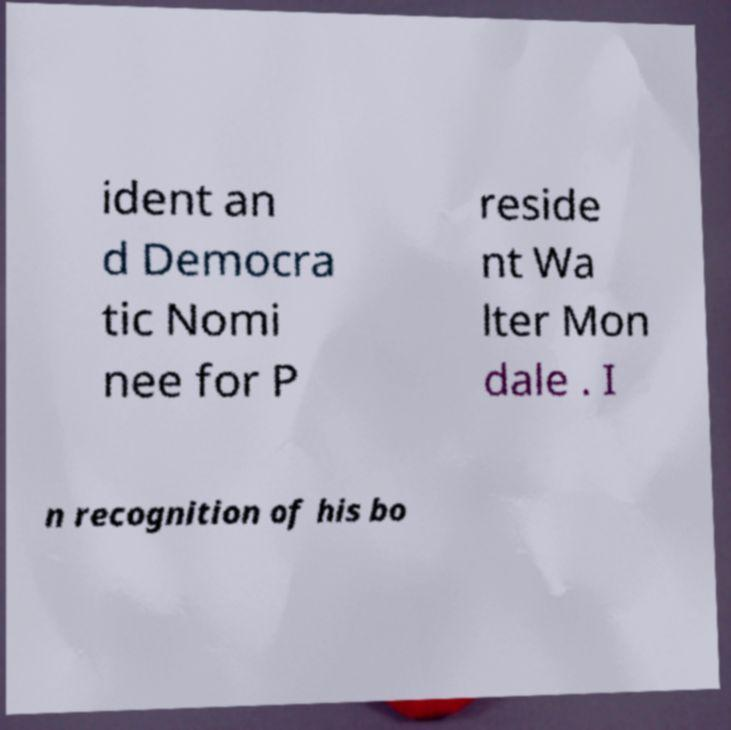Please read and relay the text visible in this image. What does it say? ident an d Democra tic Nomi nee for P reside nt Wa lter Mon dale . I n recognition of his bo 